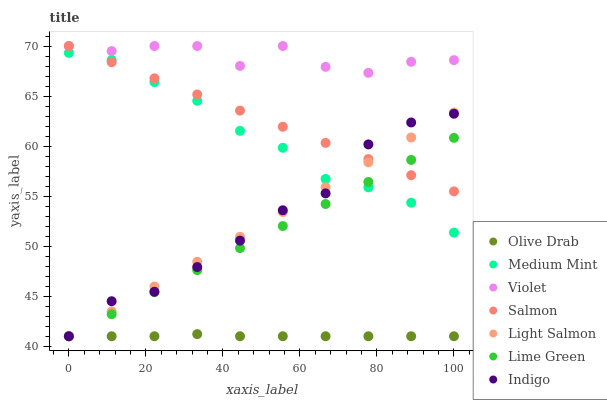Does Olive Drab have the minimum area under the curve?
Answer yes or no. Yes. Does Violet have the maximum area under the curve?
Answer yes or no. Yes. Does Light Salmon have the minimum area under the curve?
Answer yes or no. No. Does Light Salmon have the maximum area under the curve?
Answer yes or no. No. Is Lime Green the smoothest?
Answer yes or no. Yes. Is Violet the roughest?
Answer yes or no. Yes. Is Light Salmon the smoothest?
Answer yes or no. No. Is Light Salmon the roughest?
Answer yes or no. No. Does Light Salmon have the lowest value?
Answer yes or no. Yes. Does Salmon have the lowest value?
Answer yes or no. No. Does Violet have the highest value?
Answer yes or no. Yes. Does Light Salmon have the highest value?
Answer yes or no. No. Is Lime Green less than Violet?
Answer yes or no. Yes. Is Salmon greater than Olive Drab?
Answer yes or no. Yes. Does Salmon intersect Indigo?
Answer yes or no. Yes. Is Salmon less than Indigo?
Answer yes or no. No. Is Salmon greater than Indigo?
Answer yes or no. No. Does Lime Green intersect Violet?
Answer yes or no. No. 